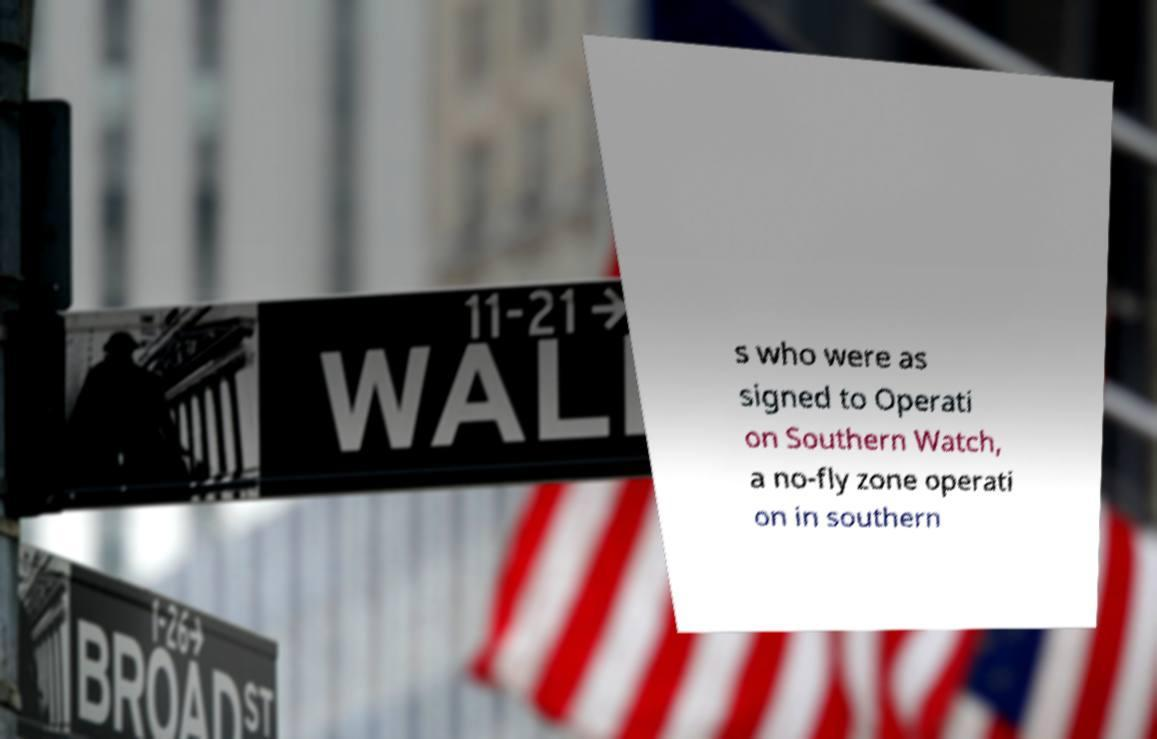Can you read and provide the text displayed in the image?This photo seems to have some interesting text. Can you extract and type it out for me? s who were as signed to Operati on Southern Watch, a no-fly zone operati on in southern 